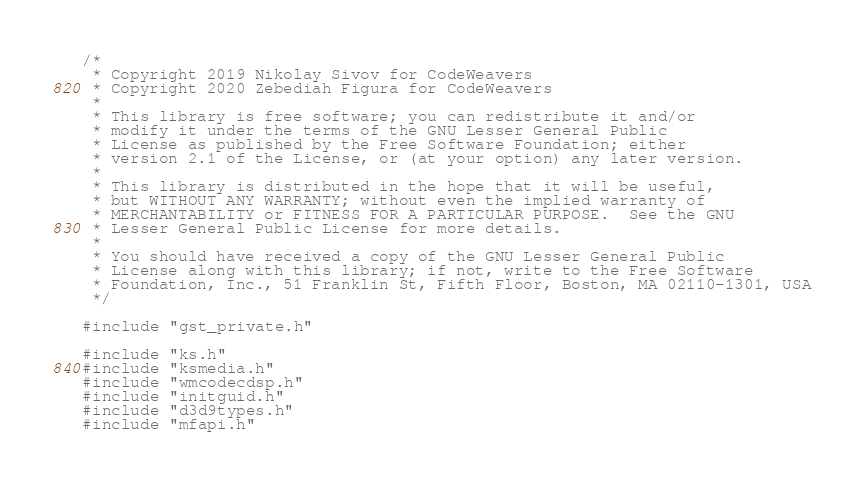Convert code to text. <code><loc_0><loc_0><loc_500><loc_500><_C_>/*
 * Copyright 2019 Nikolay Sivov for CodeWeavers
 * Copyright 2020 Zebediah Figura for CodeWeavers
 *
 * This library is free software; you can redistribute it and/or
 * modify it under the terms of the GNU Lesser General Public
 * License as published by the Free Software Foundation; either
 * version 2.1 of the License, or (at your option) any later version.
 *
 * This library is distributed in the hope that it will be useful,
 * but WITHOUT ANY WARRANTY; without even the implied warranty of
 * MERCHANTABILITY or FITNESS FOR A PARTICULAR PURPOSE.  See the GNU
 * Lesser General Public License for more details.
 *
 * You should have received a copy of the GNU Lesser General Public
 * License along with this library; if not, write to the Free Software
 * Foundation, Inc., 51 Franklin St, Fifth Floor, Boston, MA 02110-1301, USA
 */

#include "gst_private.h"

#include "ks.h"
#include "ksmedia.h"
#include "wmcodecdsp.h"
#include "initguid.h"
#include "d3d9types.h"
#include "mfapi.h"
</code> 